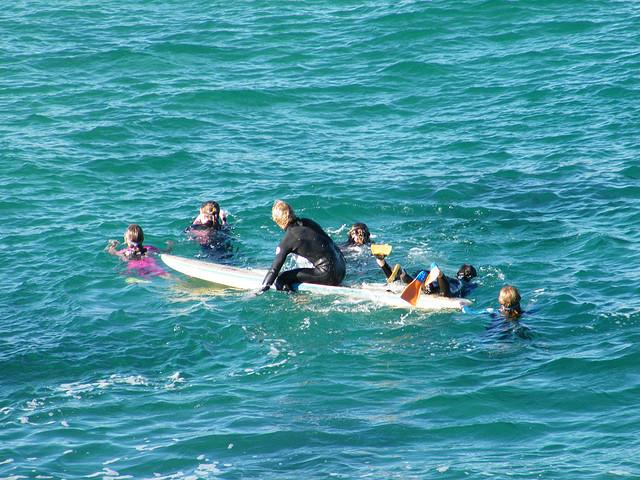How many people are in the water?
Concise answer only. 6. Is there a surfboard?
Quick response, please. Yes. Is there a shark in the picture?
Short answer required. No. 